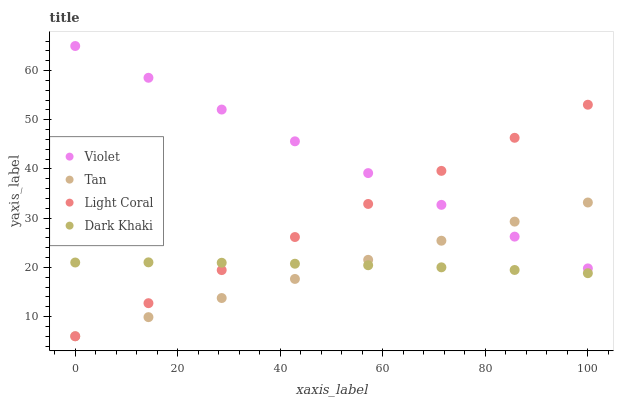Does Tan have the minimum area under the curve?
Answer yes or no. Yes. Does Violet have the maximum area under the curve?
Answer yes or no. Yes. Does Dark Khaki have the minimum area under the curve?
Answer yes or no. No. Does Dark Khaki have the maximum area under the curve?
Answer yes or no. No. Is Tan the smoothest?
Answer yes or no. Yes. Is Dark Khaki the roughest?
Answer yes or no. Yes. Is Dark Khaki the smoothest?
Answer yes or no. No. Is Tan the roughest?
Answer yes or no. No. Does Light Coral have the lowest value?
Answer yes or no. Yes. Does Dark Khaki have the lowest value?
Answer yes or no. No. Does Violet have the highest value?
Answer yes or no. Yes. Does Tan have the highest value?
Answer yes or no. No. Is Dark Khaki less than Violet?
Answer yes or no. Yes. Is Violet greater than Dark Khaki?
Answer yes or no. Yes. Does Dark Khaki intersect Tan?
Answer yes or no. Yes. Is Dark Khaki less than Tan?
Answer yes or no. No. Is Dark Khaki greater than Tan?
Answer yes or no. No. Does Dark Khaki intersect Violet?
Answer yes or no. No. 